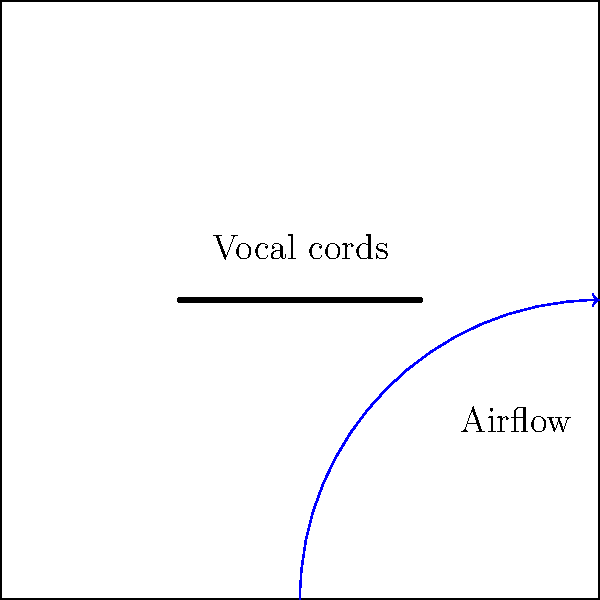In the context of rapid speech during an auction, how does the increased airflow affect the vibration frequency of the vocal cords, and what impact does this have on pitch? To understand the impact of increased airflow on vocal cord vibration and pitch during rapid speech:

1. Airflow mechanics:
   - During rapid speech, auctioneers increase their airflow from the lungs.
   - This increased air pressure causes the vocal cords to open and close more rapidly.

2. Vocal cord vibration:
   - The frequency of vocal cord vibration is directly related to the rate of air passing through them.
   - As airflow increases, the vocal cords vibrate more frequently.

3. Bernoulli effect:
   - The Bernoulli principle states that as the velocity of a fluid increases, its pressure decreases.
   - This effect helps to draw the vocal cords together more quickly as air rushes between them.

4. Pitch production:
   - Pitch is determined by the frequency of vocal cord vibration.
   - Higher frequency vibrations produce higher pitches.

5. Impact on auctioneer's speech:
   - The increased airflow and resulting higher vibration frequency lead to a higher overall pitch in the auctioneer's voice.
   - This higher pitch helps the auctioneer's voice to carry further and be more distinct in a crowded auction environment.

In summary, the increased airflow during rapid speech causes the vocal cords to vibrate at a higher frequency, resulting in a higher pitch that is characteristic of an auctioneer's chant.
Answer: Increased airflow raises vocal cord vibration frequency, producing higher pitch. 